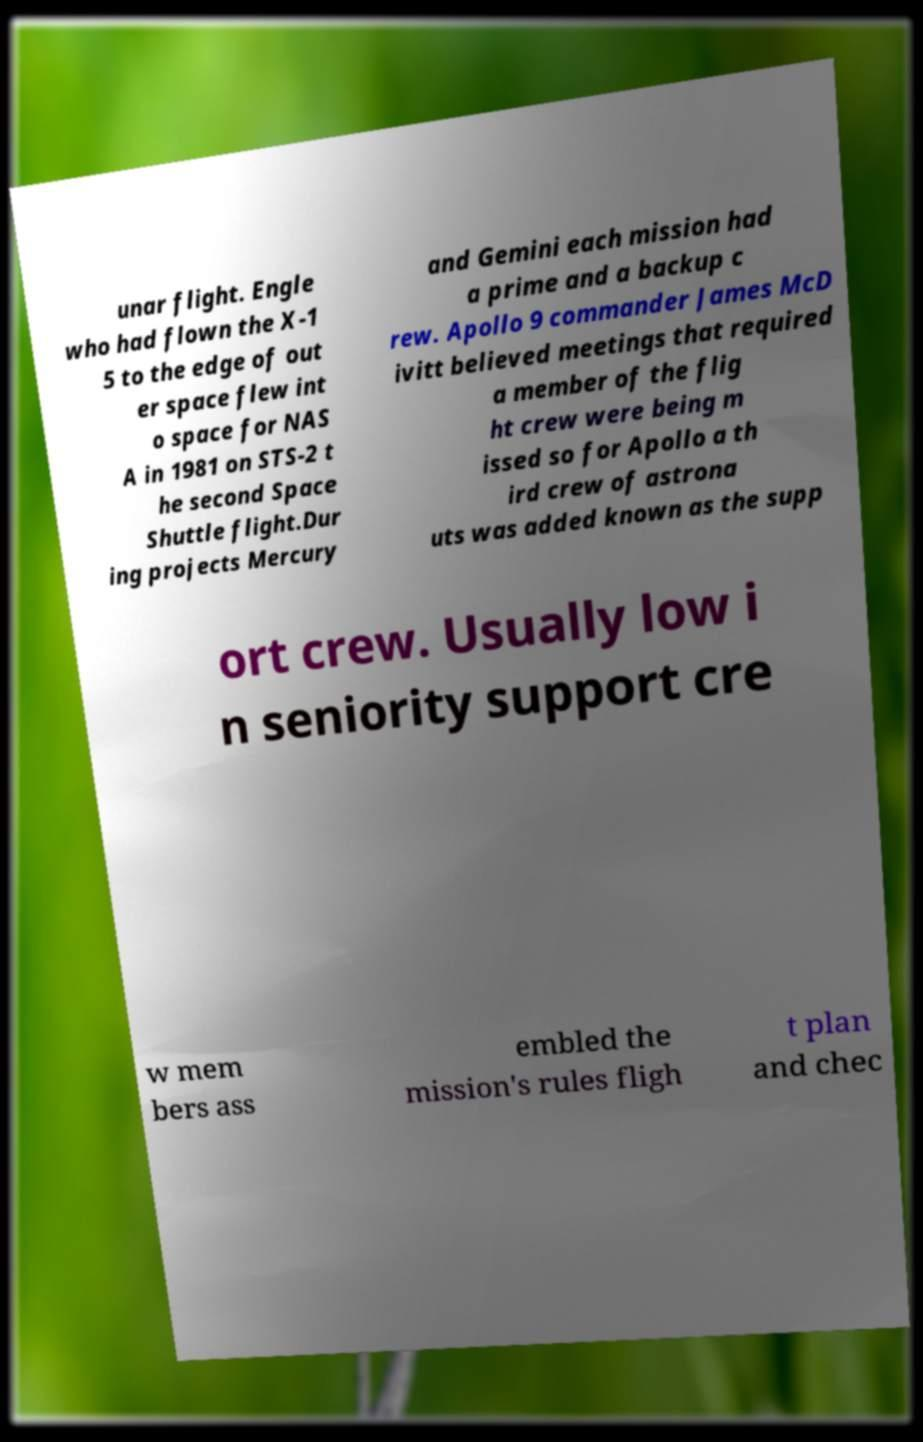Could you extract and type out the text from this image? unar flight. Engle who had flown the X-1 5 to the edge of out er space flew int o space for NAS A in 1981 on STS-2 t he second Space Shuttle flight.Dur ing projects Mercury and Gemini each mission had a prime and a backup c rew. Apollo 9 commander James McD ivitt believed meetings that required a member of the flig ht crew were being m issed so for Apollo a th ird crew of astrona uts was added known as the supp ort crew. Usually low i n seniority support cre w mem bers ass embled the mission's rules fligh t plan and chec 